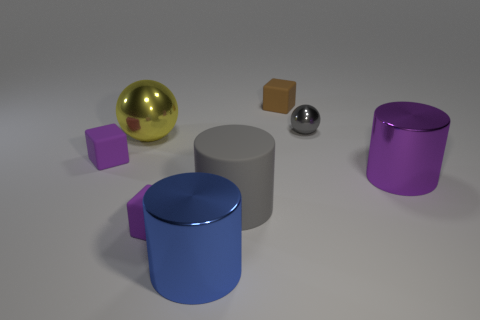Add 2 big blue cubes. How many objects exist? 10 Subtract all balls. How many objects are left? 6 Subtract 0 red blocks. How many objects are left? 8 Subtract all small brown matte blocks. Subtract all small blocks. How many objects are left? 4 Add 3 blue metallic objects. How many blue metallic objects are left? 4 Add 8 matte cylinders. How many matte cylinders exist? 9 